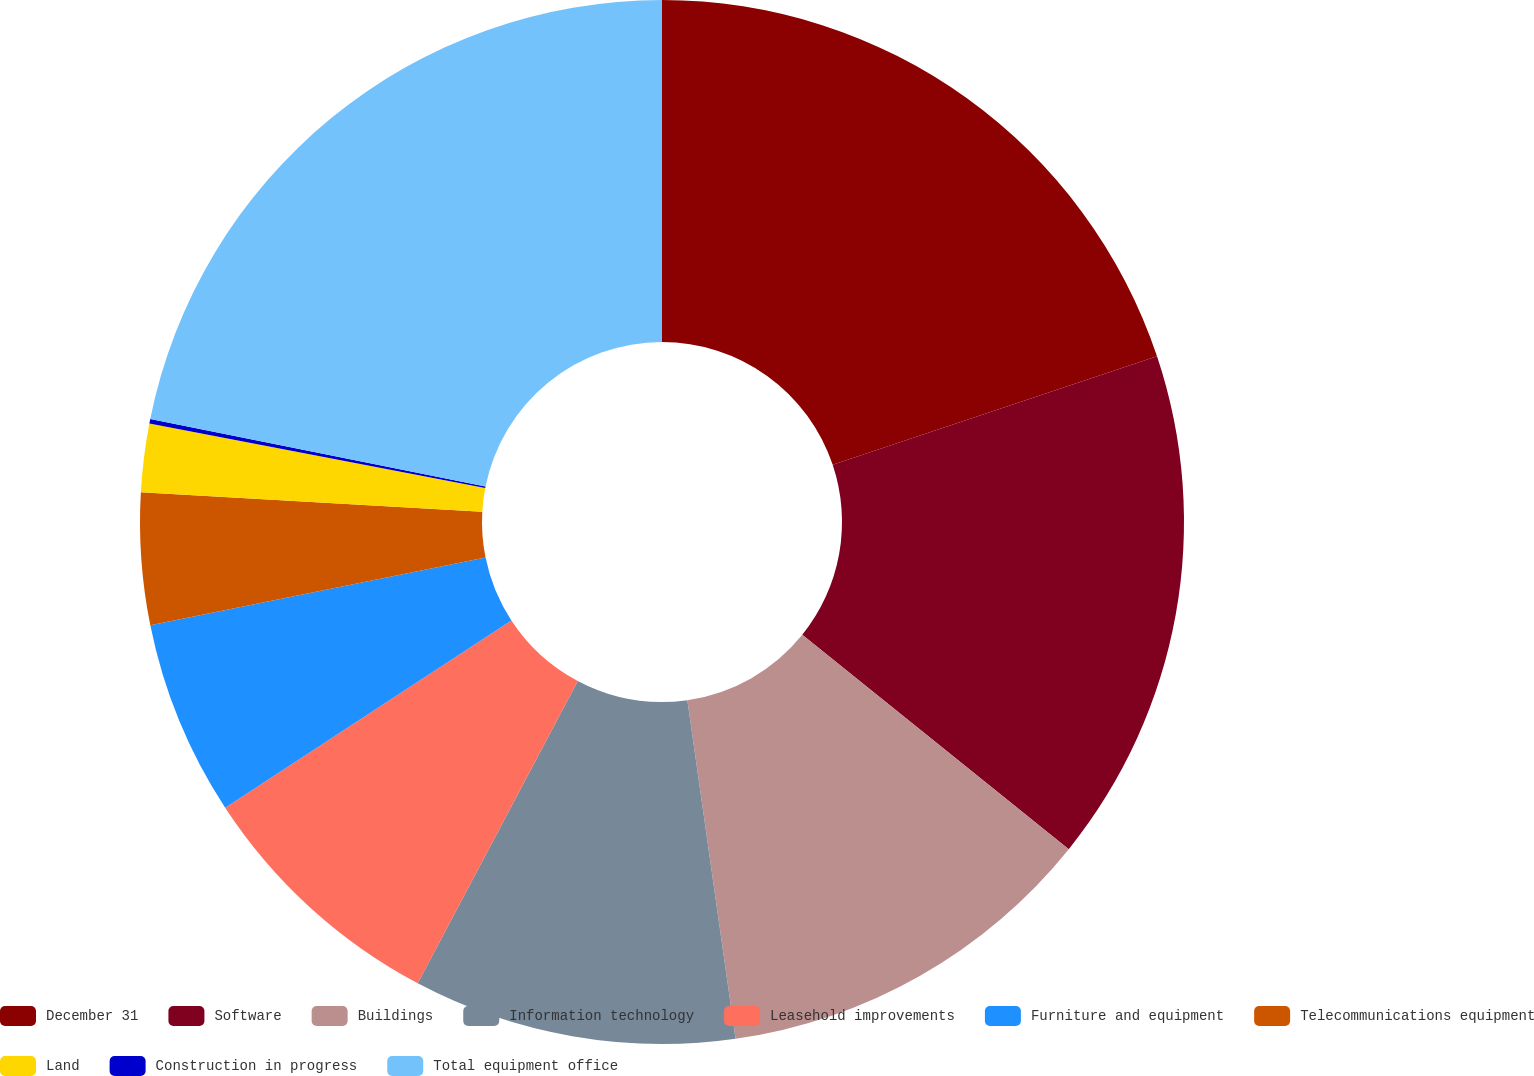<chart> <loc_0><loc_0><loc_500><loc_500><pie_chart><fcel>December 31<fcel>Software<fcel>Buildings<fcel>Information technology<fcel>Leasehold improvements<fcel>Furniture and equipment<fcel>Telecommunications equipment<fcel>Land<fcel>Construction in progress<fcel>Total equipment office<nl><fcel>19.86%<fcel>15.92%<fcel>11.97%<fcel>10.0%<fcel>8.03%<fcel>6.05%<fcel>4.08%<fcel>2.11%<fcel>0.14%<fcel>21.84%<nl></chart> 